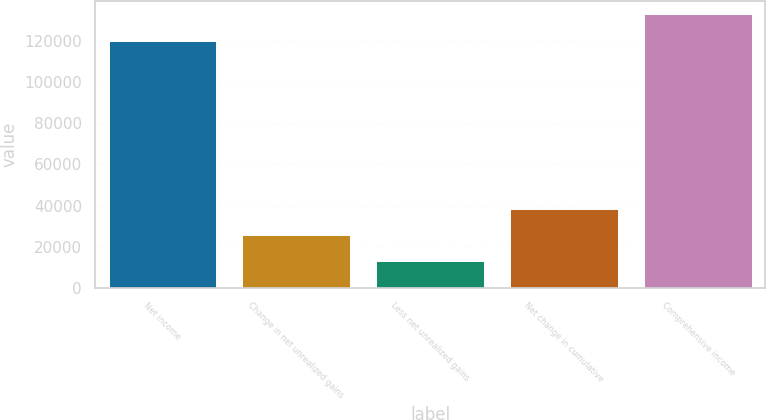Convert chart to OTSL. <chart><loc_0><loc_0><loc_500><loc_500><bar_chart><fcel>Net income<fcel>Change in net unrealized gains<fcel>Less net unrealized gains<fcel>Net change in cumulative<fcel>Comprehensive income<nl><fcel>120316<fcel>25791.6<fcel>13124.3<fcel>38458.9<fcel>132983<nl></chart> 